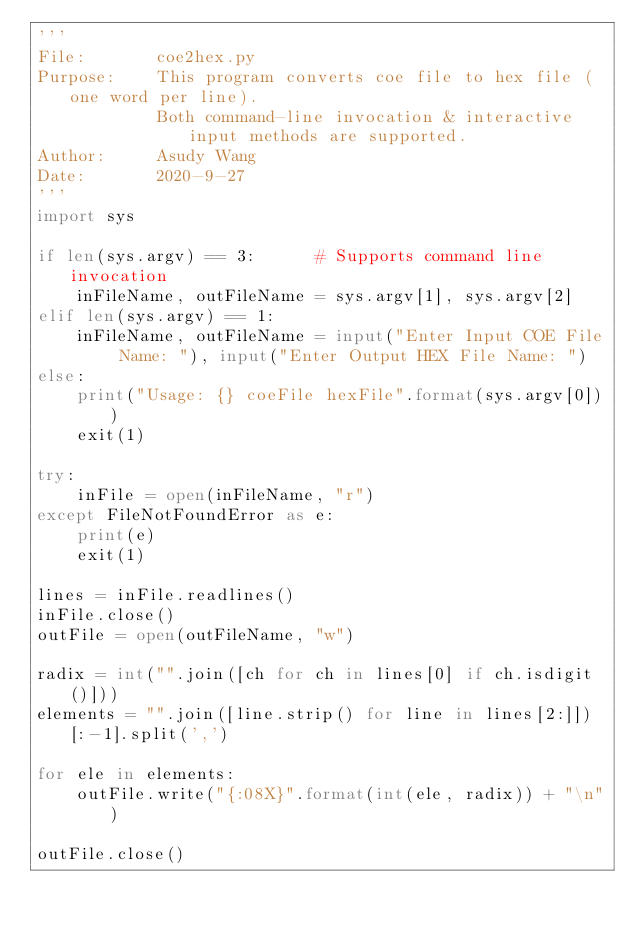Convert code to text. <code><loc_0><loc_0><loc_500><loc_500><_Python_>'''
File:       coe2hex.py
Purpose:    This program converts coe file to hex file (one word per line).
            Both command-line invocation & interactive input methods are supported.
Author:     Asudy Wang
Date:       2020-9-27
'''
import sys

if len(sys.argv) == 3:      # Supports command line invocation
    inFileName, outFileName = sys.argv[1], sys.argv[2]
elif len(sys.argv) == 1:
    inFileName, outFileName = input("Enter Input COE File Name: "), input("Enter Output HEX File Name: ")
else:
    print("Usage: {} coeFile hexFile".format(sys.argv[0]))
    exit(1)

try:
    inFile = open(inFileName, "r")
except FileNotFoundError as e:
    print(e)
    exit(1)

lines = inFile.readlines()
inFile.close()
outFile = open(outFileName, "w")

radix = int("".join([ch for ch in lines[0] if ch.isdigit()]))
elements = "".join([line.strip() for line in lines[2:]])[:-1].split(',')

for ele in elements:
    outFile.write("{:08X}".format(int(ele, radix)) + "\n")

outFile.close()</code> 